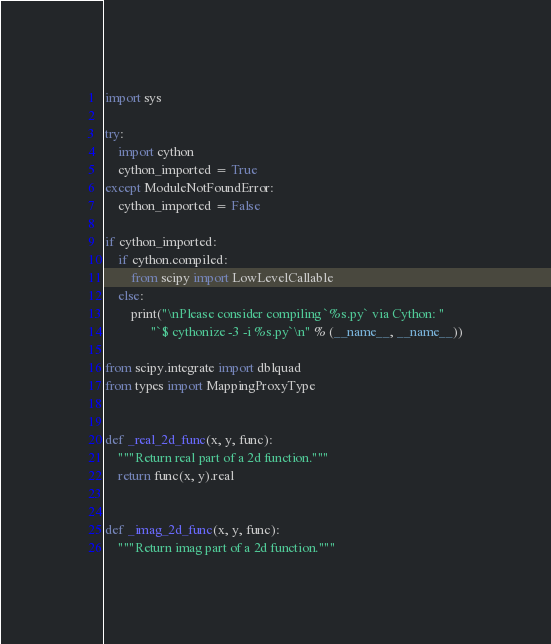Convert code to text. <code><loc_0><loc_0><loc_500><loc_500><_Python_>
import sys

try:
    import cython
    cython_imported = True
except ModuleNotFoundError:
    cython_imported = False

if cython_imported:
    if cython.compiled:
        from scipy import LowLevelCallable
    else:
        print("\nPlease consider compiling `%s.py` via Cython: "
              "`$ cythonize -3 -i %s.py`\n" % (__name__, __name__))

from scipy.integrate import dblquad
from types import MappingProxyType


def _real_2d_func(x, y, func):
    """Return real part of a 2d function."""
    return func(x, y).real


def _imag_2d_func(x, y, func):
    """Return imag part of a 2d function."""</code> 